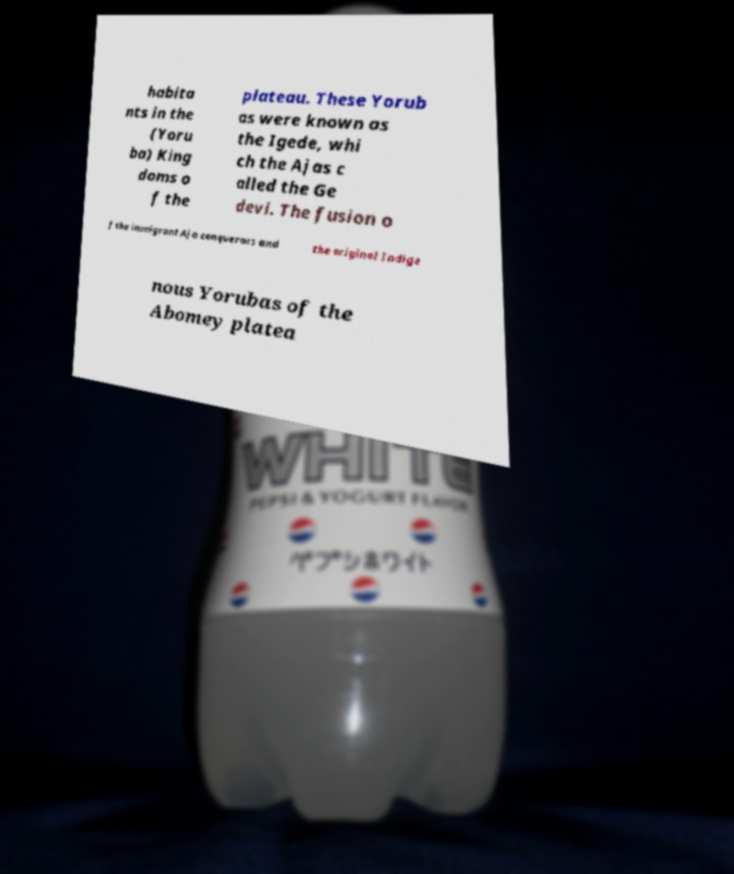Can you read and provide the text displayed in the image?This photo seems to have some interesting text. Can you extract and type it out for me? habita nts in the (Yoru ba) King doms o f the plateau. These Yorub as were known as the Igede, whi ch the Ajas c alled the Ge devi. The fusion o f the immigrant Aja conquerors and the original Indige nous Yorubas of the Abomey platea 